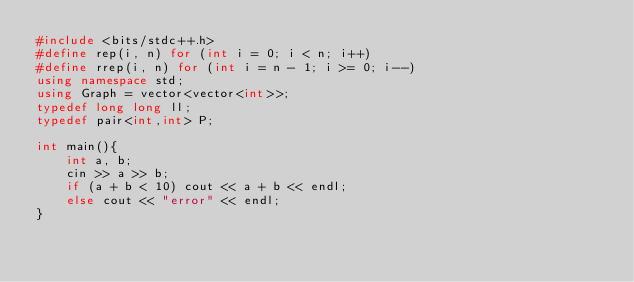<code> <loc_0><loc_0><loc_500><loc_500><_C++_>#include <bits/stdc++.h>
#define rep(i, n) for (int i = 0; i < n; i++)
#define rrep(i, n) for (int i = n - 1; i >= 0; i--)
using namespace std;
using Graph = vector<vector<int>>;
typedef long long ll;
typedef pair<int,int> P;

int main(){
    int a, b;
    cin >> a >> b;
    if (a + b < 10) cout << a + b << endl;
    else cout << "error" << endl;
}</code> 